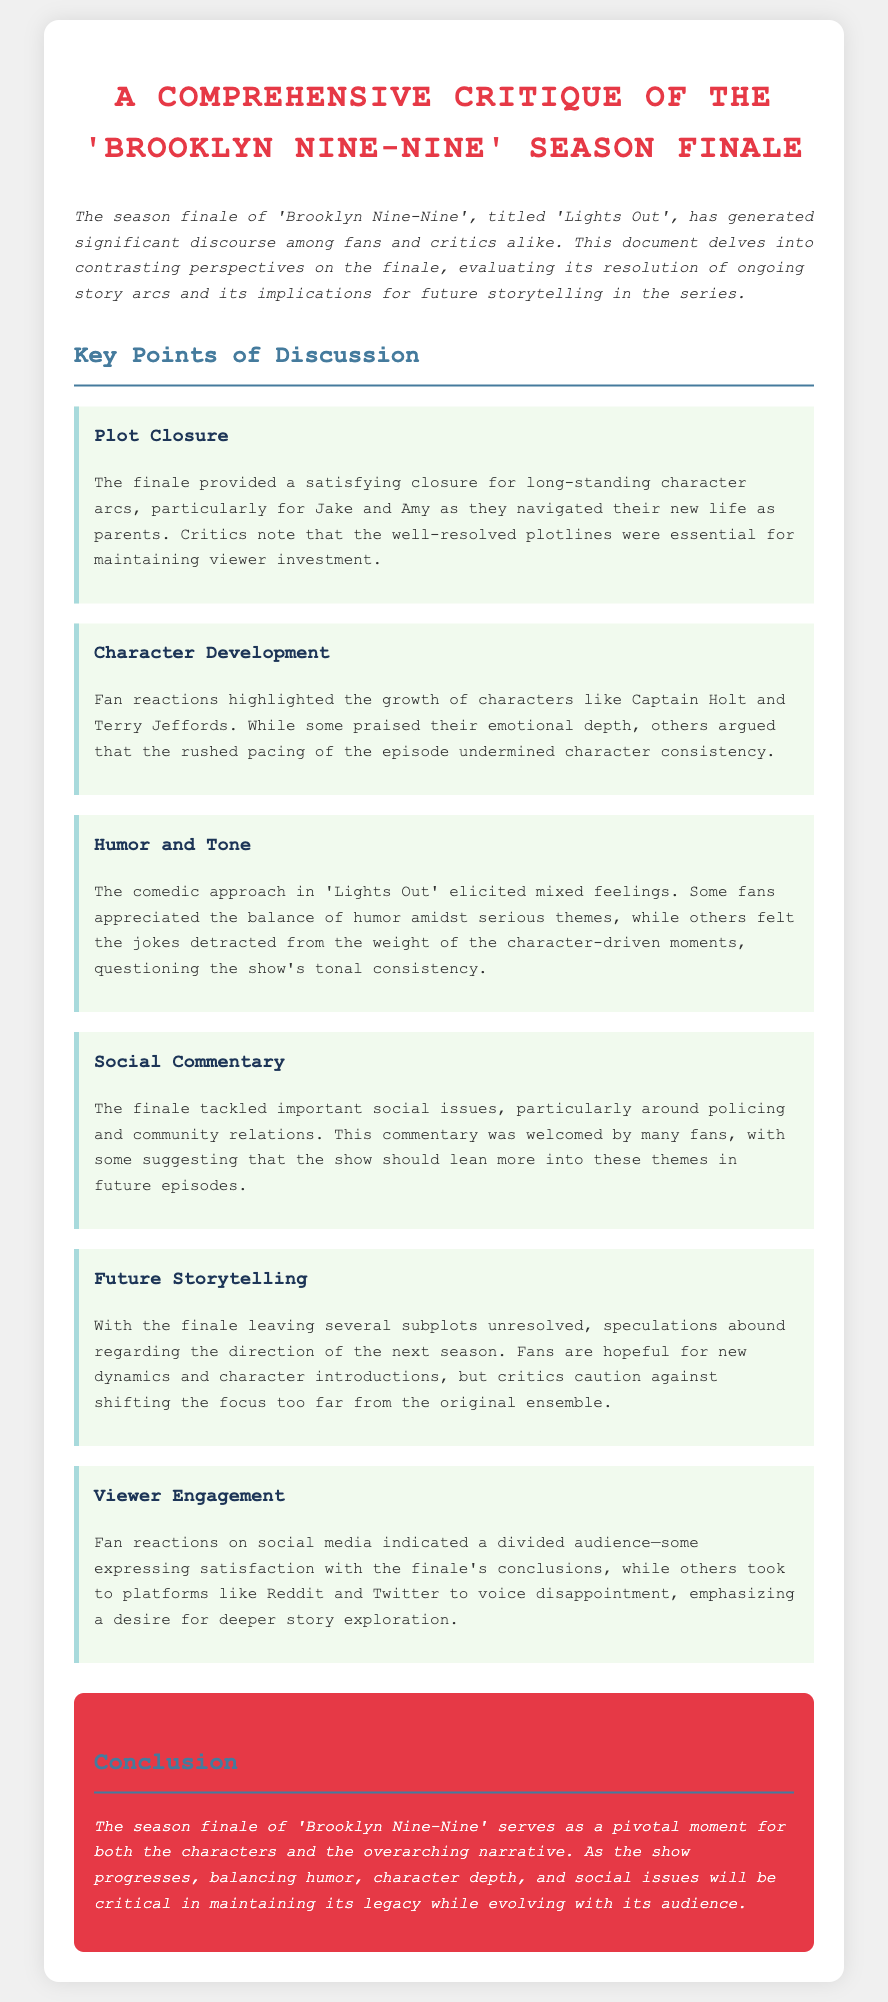What is the title of the finale episode? The title of the finale episode is mentioned in the introduction of the document as 'Lights Out'.
Answer: Lights Out What theme is explored in the finale regarding community relations? The document discusses the finale tackling important social issues around policing and community relations.
Answer: Policing and community relations Which characters' development was highlighted by fan reactions? The key point on character development mentions the growth of Captain Holt and Terry Jeffords.
Answer: Captain Holt and Terry Jeffords What was a major criticism regarding the episode's pacing? Critics argued that the rushed pacing of the episode undermined character consistency, as stated in the character development section.
Answer: Rushed pacing What type of reactions did fans express on social media? The final key point notes that fan reactions on social media indicated a divided audience.
Answer: Divided audience What does the conclusion emphasize as critical for the show's progress? The conclusion of the document emphasizes balancing humor, character depth, and social issues as critical for maintaining the show's legacy.
Answer: Balancing humor, character depth, and social issues How did the finale resolve character arcs, particularly for Jake and Amy? The critique states that the finale provided a satisfying closure for long-standing character arcs for Jake and Amy.
Answer: Satisfying closure What kind of future storytelling do fans speculate about? The document mentions that fans are hopeful for new dynamics and character introductions in future storytelling.
Answer: New dynamics and character introductions 